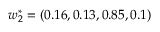Convert formula to latex. <formula><loc_0><loc_0><loc_500><loc_500>w _ { 2 } ^ { * } = ( 0 . 1 6 , 0 . 1 3 , 0 . 8 5 , 0 . 1 )</formula> 